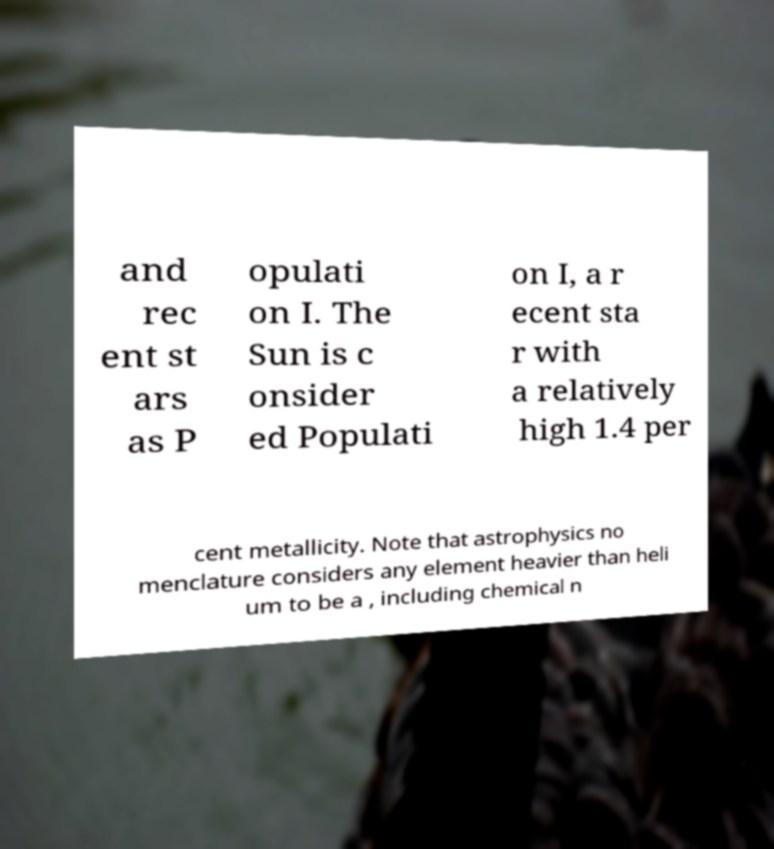There's text embedded in this image that I need extracted. Can you transcribe it verbatim? and rec ent st ars as P opulati on I. The Sun is c onsider ed Populati on I, a r ecent sta r with a relatively high 1.4 per cent metallicity. Note that astrophysics no menclature considers any element heavier than heli um to be a , including chemical n 